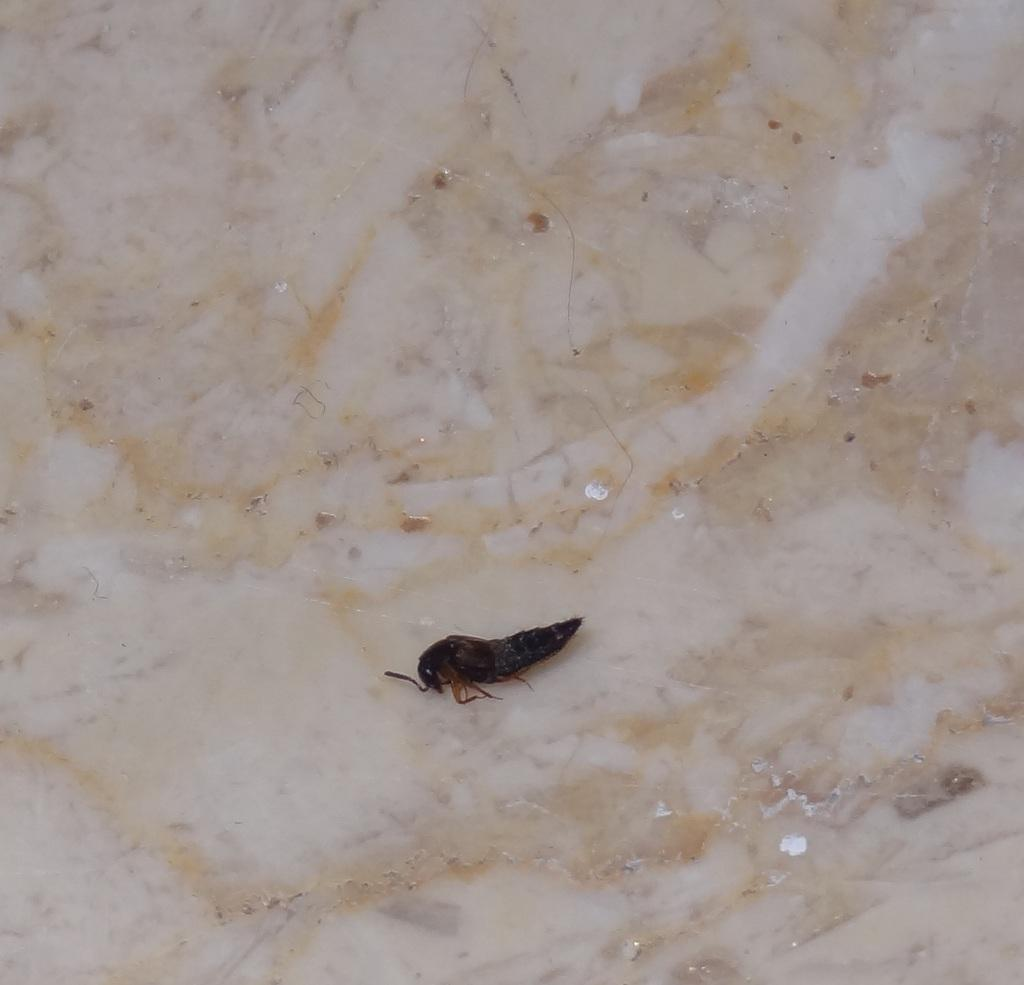What type of creature can be seen in the image? There is an insect in the image. Where is the insect located in the image? The insect is on the floor. What type of dress is the insect wearing in the image? There is no dress present in the image, as insects do not wear clothing. 